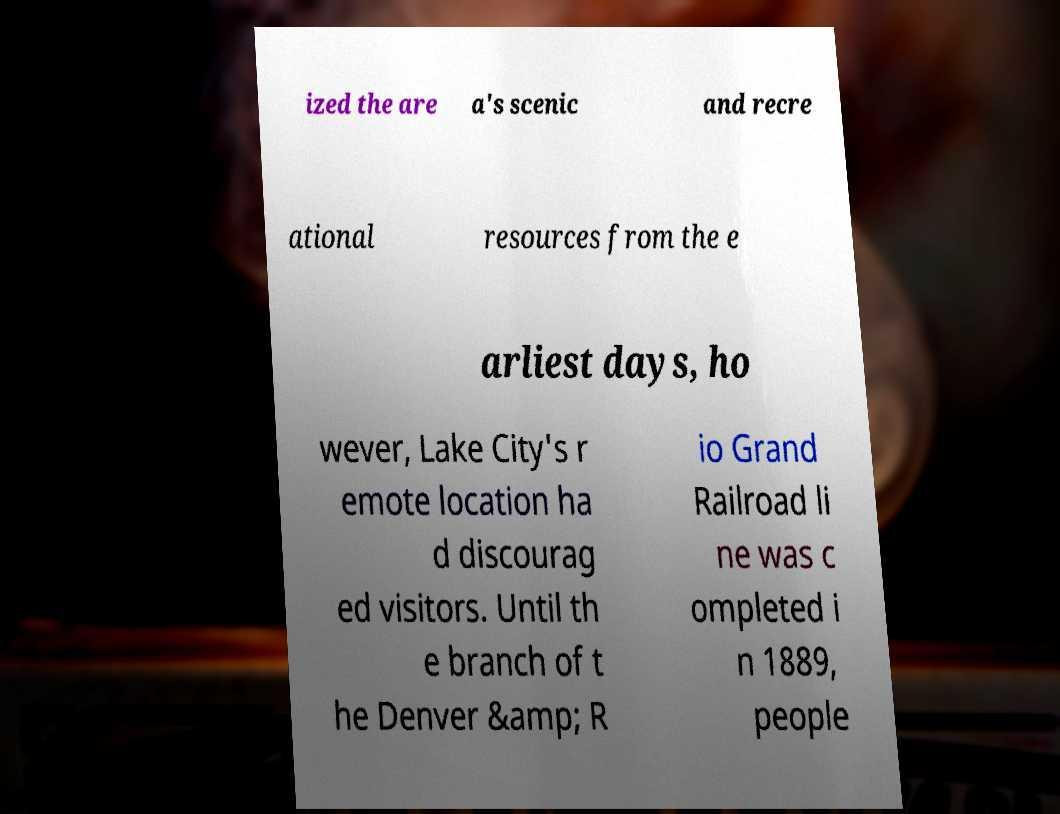Please read and relay the text visible in this image. What does it say? ized the are a's scenic and recre ational resources from the e arliest days, ho wever, Lake City's r emote location ha d discourag ed visitors. Until th e branch of t he Denver &amp; R io Grand Railroad li ne was c ompleted i n 1889, people 